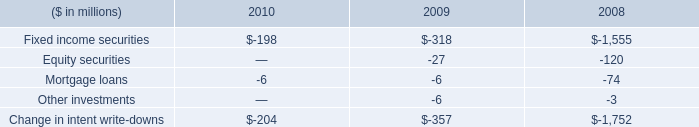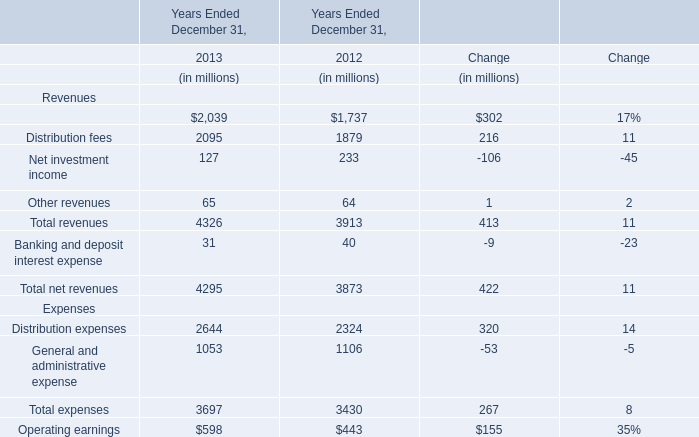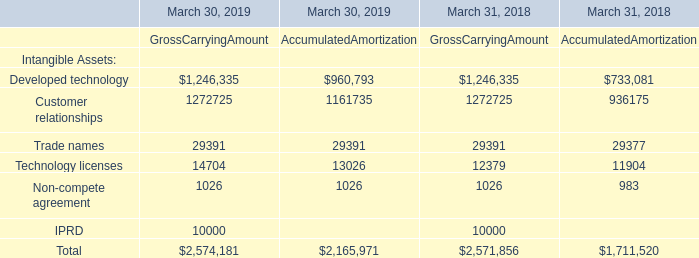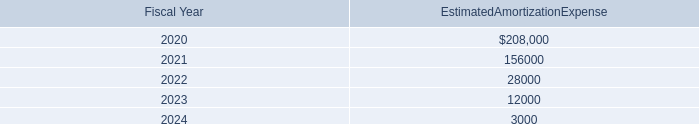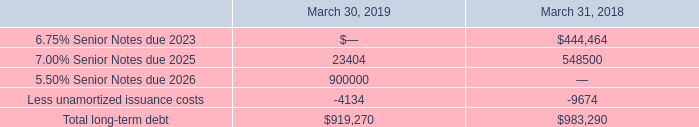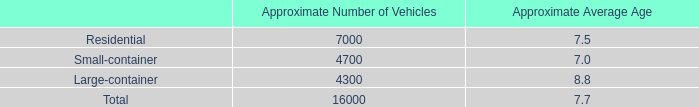What's the average of Management and financial advice fees in 2013 and 2012? (in dollars in millions) 
Computations: ((2039 + 1737) / 2)
Answer: 1888.0. 